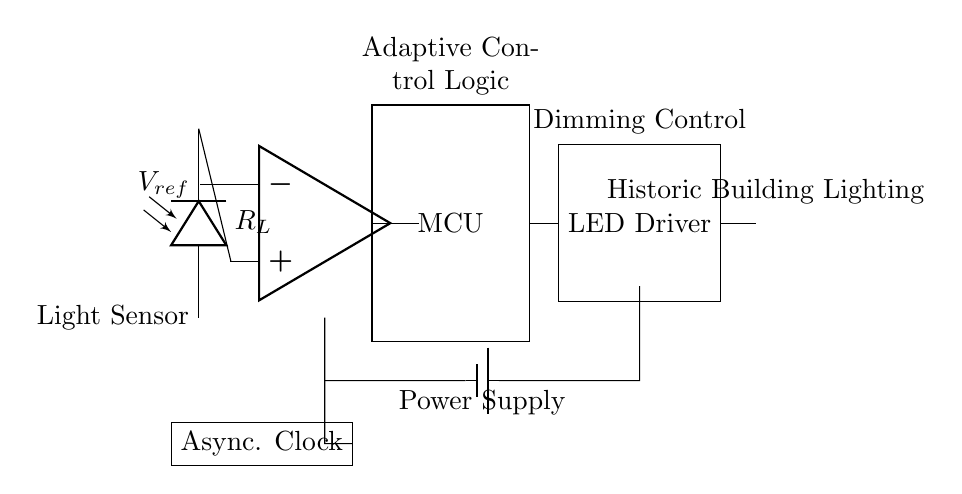What component is used for light detection in this circuit? The circuit features a photodiode, specifically labeled as the light sensor, which detects the light levels.
Answer: Photodiode How many resistors are present in the circuit diagram? In the provided diagram, there is one identified resistor, represented as R_L connected to the photodiode.
Answer: One What does the MCU stand for in the context of this circuit? MCU refers to the Microcontroller Unit, which is responsible for adaptive control logic in the circuit.
Answer: Microcontroller Unit What is the function of the asynchronous clock in this circuit? The asynchronous clock provides timing signals to the circuit, allowing components to operate in a coordinated manner without being driven by a common clock source.
Answer: Timing signals How does the LED driver receive control signals? The LED driver receives control signals from the Microcontroller Unit, which processes the output from the comparator and adjusts LED brightness accordingly.
Answer: Microcontroller Unit Where is the power supply located in the circuit? The power supply is indicated at the bottom of the circuit diagram, feeding power to various components.
Answer: Bottom of the circuit What type of control does the adaptive control logic provide? The adaptive control logic analyzes light levels and adjusts the output to the LED Driver based on environmental conditions, providing dimming control for efficiency and ambiance.
Answer: Dimming control 